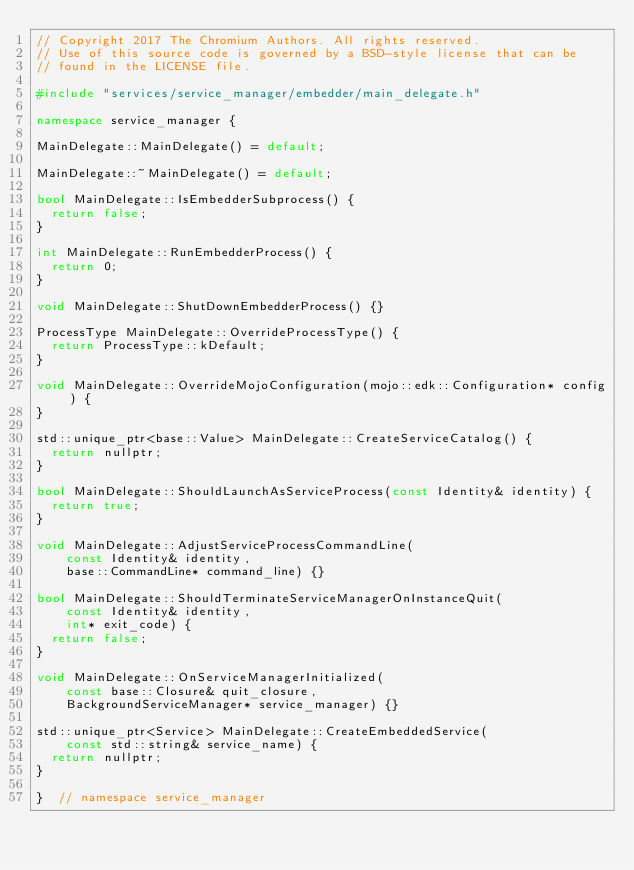<code> <loc_0><loc_0><loc_500><loc_500><_C++_>// Copyright 2017 The Chromium Authors. All rights reserved.
// Use of this source code is governed by a BSD-style license that can be
// found in the LICENSE file.

#include "services/service_manager/embedder/main_delegate.h"

namespace service_manager {

MainDelegate::MainDelegate() = default;

MainDelegate::~MainDelegate() = default;

bool MainDelegate::IsEmbedderSubprocess() {
  return false;
}

int MainDelegate::RunEmbedderProcess() {
  return 0;
}

void MainDelegate::ShutDownEmbedderProcess() {}

ProcessType MainDelegate::OverrideProcessType() {
  return ProcessType::kDefault;
}

void MainDelegate::OverrideMojoConfiguration(mojo::edk::Configuration* config) {
}

std::unique_ptr<base::Value> MainDelegate::CreateServiceCatalog() {
  return nullptr;
}

bool MainDelegate::ShouldLaunchAsServiceProcess(const Identity& identity) {
  return true;
}

void MainDelegate::AdjustServiceProcessCommandLine(
    const Identity& identity,
    base::CommandLine* command_line) {}

bool MainDelegate::ShouldTerminateServiceManagerOnInstanceQuit(
    const Identity& identity,
    int* exit_code) {
  return false;
}

void MainDelegate::OnServiceManagerInitialized(
    const base::Closure& quit_closure,
    BackgroundServiceManager* service_manager) {}

std::unique_ptr<Service> MainDelegate::CreateEmbeddedService(
    const std::string& service_name) {
  return nullptr;
}

}  // namespace service_manager
</code> 